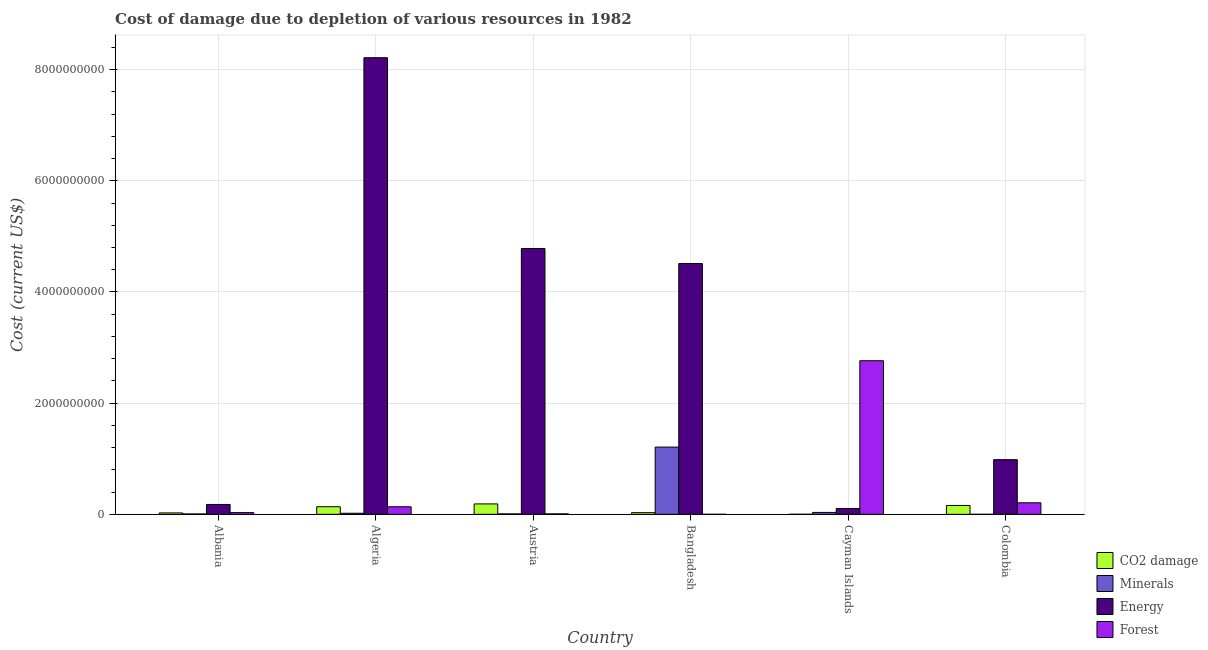Are the number of bars per tick equal to the number of legend labels?
Provide a short and direct response. Yes. Are the number of bars on each tick of the X-axis equal?
Provide a short and direct response. Yes. How many bars are there on the 3rd tick from the left?
Your answer should be compact. 4. What is the label of the 1st group of bars from the left?
Your answer should be very brief. Albania. In how many cases, is the number of bars for a given country not equal to the number of legend labels?
Keep it short and to the point. 0. What is the cost of damage due to depletion of forests in Bangladesh?
Keep it short and to the point. 2.95e+05. Across all countries, what is the maximum cost of damage due to depletion of forests?
Provide a short and direct response. 2.76e+09. Across all countries, what is the minimum cost of damage due to depletion of energy?
Your answer should be very brief. 1.05e+08. In which country was the cost of damage due to depletion of minerals maximum?
Give a very brief answer. Bangladesh. In which country was the cost of damage due to depletion of forests minimum?
Ensure brevity in your answer.  Bangladesh. What is the total cost of damage due to depletion of forests in the graph?
Provide a succinct answer. 3.15e+09. What is the difference between the cost of damage due to depletion of coal in Austria and that in Colombia?
Your answer should be very brief. 2.76e+07. What is the difference between the cost of damage due to depletion of energy in Cayman Islands and the cost of damage due to depletion of coal in Austria?
Provide a short and direct response. -8.20e+07. What is the average cost of damage due to depletion of energy per country?
Your answer should be very brief. 3.13e+09. What is the difference between the cost of damage due to depletion of energy and cost of damage due to depletion of minerals in Albania?
Provide a succinct answer. 1.71e+08. In how many countries, is the cost of damage due to depletion of forests greater than 2000000000 US$?
Offer a very short reply. 1. What is the ratio of the cost of damage due to depletion of forests in Algeria to that in Cayman Islands?
Your answer should be compact. 0.05. What is the difference between the highest and the second highest cost of damage due to depletion of minerals?
Your answer should be very brief. 1.18e+09. What is the difference between the highest and the lowest cost of damage due to depletion of forests?
Provide a succinct answer. 2.76e+09. In how many countries, is the cost of damage due to depletion of minerals greater than the average cost of damage due to depletion of minerals taken over all countries?
Ensure brevity in your answer.  1. Is the sum of the cost of damage due to depletion of minerals in Cayman Islands and Colombia greater than the maximum cost of damage due to depletion of forests across all countries?
Keep it short and to the point. No. Is it the case that in every country, the sum of the cost of damage due to depletion of coal and cost of damage due to depletion of forests is greater than the sum of cost of damage due to depletion of energy and cost of damage due to depletion of minerals?
Ensure brevity in your answer.  No. What does the 4th bar from the left in Cayman Islands represents?
Offer a terse response. Forest. What does the 2nd bar from the right in Albania represents?
Your answer should be very brief. Energy. How many bars are there?
Ensure brevity in your answer.  24. Are all the bars in the graph horizontal?
Your response must be concise. No. Does the graph contain any zero values?
Your response must be concise. No. Does the graph contain grids?
Give a very brief answer. Yes. How many legend labels are there?
Provide a succinct answer. 4. How are the legend labels stacked?
Make the answer very short. Vertical. What is the title of the graph?
Offer a terse response. Cost of damage due to depletion of various resources in 1982 . What is the label or title of the Y-axis?
Offer a terse response. Cost (current US$). What is the Cost (current US$) of CO2 damage in Albania?
Give a very brief answer. 2.54e+07. What is the Cost (current US$) in Minerals in Albania?
Make the answer very short. 6.87e+06. What is the Cost (current US$) in Energy in Albania?
Make the answer very short. 1.77e+08. What is the Cost (current US$) in Forest in Albania?
Ensure brevity in your answer.  3.07e+07. What is the Cost (current US$) in CO2 damage in Algeria?
Your answer should be compact. 1.36e+08. What is the Cost (current US$) in Minerals in Algeria?
Offer a terse response. 1.92e+07. What is the Cost (current US$) in Energy in Algeria?
Keep it short and to the point. 8.21e+09. What is the Cost (current US$) in Forest in Algeria?
Keep it short and to the point. 1.36e+08. What is the Cost (current US$) of CO2 damage in Austria?
Your answer should be very brief. 1.87e+08. What is the Cost (current US$) in Minerals in Austria?
Offer a terse response. 7.86e+06. What is the Cost (current US$) in Energy in Austria?
Offer a terse response. 4.78e+09. What is the Cost (current US$) in Forest in Austria?
Provide a short and direct response. 8.02e+06. What is the Cost (current US$) in CO2 damage in Bangladesh?
Give a very brief answer. 2.99e+07. What is the Cost (current US$) of Minerals in Bangladesh?
Make the answer very short. 1.21e+09. What is the Cost (current US$) of Energy in Bangladesh?
Give a very brief answer. 4.51e+09. What is the Cost (current US$) in Forest in Bangladesh?
Your answer should be compact. 2.95e+05. What is the Cost (current US$) in CO2 damage in Cayman Islands?
Give a very brief answer. 5.73e+05. What is the Cost (current US$) in Minerals in Cayman Islands?
Keep it short and to the point. 3.43e+07. What is the Cost (current US$) in Energy in Cayman Islands?
Give a very brief answer. 1.05e+08. What is the Cost (current US$) of Forest in Cayman Islands?
Your answer should be compact. 2.76e+09. What is the Cost (current US$) in CO2 damage in Colombia?
Give a very brief answer. 1.59e+08. What is the Cost (current US$) of Minerals in Colombia?
Give a very brief answer. 7726.01. What is the Cost (current US$) of Energy in Colombia?
Give a very brief answer. 9.83e+08. What is the Cost (current US$) in Forest in Colombia?
Your answer should be compact. 2.08e+08. Across all countries, what is the maximum Cost (current US$) of CO2 damage?
Your answer should be very brief. 1.87e+08. Across all countries, what is the maximum Cost (current US$) in Minerals?
Make the answer very short. 1.21e+09. Across all countries, what is the maximum Cost (current US$) in Energy?
Keep it short and to the point. 8.21e+09. Across all countries, what is the maximum Cost (current US$) in Forest?
Offer a terse response. 2.76e+09. Across all countries, what is the minimum Cost (current US$) of CO2 damage?
Your response must be concise. 5.73e+05. Across all countries, what is the minimum Cost (current US$) in Minerals?
Ensure brevity in your answer.  7726.01. Across all countries, what is the minimum Cost (current US$) in Energy?
Your response must be concise. 1.05e+08. Across all countries, what is the minimum Cost (current US$) in Forest?
Provide a succinct answer. 2.95e+05. What is the total Cost (current US$) of CO2 damage in the graph?
Give a very brief answer. 5.39e+08. What is the total Cost (current US$) of Minerals in the graph?
Keep it short and to the point. 1.28e+09. What is the total Cost (current US$) of Energy in the graph?
Provide a short and direct response. 1.88e+1. What is the total Cost (current US$) in Forest in the graph?
Your response must be concise. 3.15e+09. What is the difference between the Cost (current US$) of CO2 damage in Albania and that in Algeria?
Your answer should be compact. -1.11e+08. What is the difference between the Cost (current US$) of Minerals in Albania and that in Algeria?
Your answer should be compact. -1.23e+07. What is the difference between the Cost (current US$) in Energy in Albania and that in Algeria?
Offer a very short reply. -8.04e+09. What is the difference between the Cost (current US$) in Forest in Albania and that in Algeria?
Offer a terse response. -1.05e+08. What is the difference between the Cost (current US$) of CO2 damage in Albania and that in Austria?
Your answer should be compact. -1.62e+08. What is the difference between the Cost (current US$) of Minerals in Albania and that in Austria?
Your answer should be compact. -9.95e+05. What is the difference between the Cost (current US$) of Energy in Albania and that in Austria?
Your answer should be compact. -4.60e+09. What is the difference between the Cost (current US$) in Forest in Albania and that in Austria?
Your response must be concise. 2.26e+07. What is the difference between the Cost (current US$) of CO2 damage in Albania and that in Bangladesh?
Keep it short and to the point. -4.48e+06. What is the difference between the Cost (current US$) of Minerals in Albania and that in Bangladesh?
Offer a very short reply. -1.20e+09. What is the difference between the Cost (current US$) of Energy in Albania and that in Bangladesh?
Your answer should be compact. -4.33e+09. What is the difference between the Cost (current US$) in Forest in Albania and that in Bangladesh?
Offer a terse response. 3.04e+07. What is the difference between the Cost (current US$) of CO2 damage in Albania and that in Cayman Islands?
Your answer should be very brief. 2.48e+07. What is the difference between the Cost (current US$) in Minerals in Albania and that in Cayman Islands?
Your answer should be very brief. -2.74e+07. What is the difference between the Cost (current US$) in Energy in Albania and that in Cayman Islands?
Provide a succinct answer. 7.23e+07. What is the difference between the Cost (current US$) in Forest in Albania and that in Cayman Islands?
Provide a succinct answer. -2.73e+09. What is the difference between the Cost (current US$) of CO2 damage in Albania and that in Colombia?
Provide a short and direct response. -1.34e+08. What is the difference between the Cost (current US$) in Minerals in Albania and that in Colombia?
Keep it short and to the point. 6.86e+06. What is the difference between the Cost (current US$) in Energy in Albania and that in Colombia?
Offer a terse response. -8.06e+08. What is the difference between the Cost (current US$) in Forest in Albania and that in Colombia?
Provide a succinct answer. -1.77e+08. What is the difference between the Cost (current US$) in CO2 damage in Algeria and that in Austria?
Offer a very short reply. -5.07e+07. What is the difference between the Cost (current US$) of Minerals in Algeria and that in Austria?
Keep it short and to the point. 1.13e+07. What is the difference between the Cost (current US$) of Energy in Algeria and that in Austria?
Your response must be concise. 3.43e+09. What is the difference between the Cost (current US$) of Forest in Algeria and that in Austria?
Offer a very short reply. 1.28e+08. What is the difference between the Cost (current US$) in CO2 damage in Algeria and that in Bangladesh?
Your answer should be very brief. 1.07e+08. What is the difference between the Cost (current US$) in Minerals in Algeria and that in Bangladesh?
Give a very brief answer. -1.19e+09. What is the difference between the Cost (current US$) in Energy in Algeria and that in Bangladesh?
Provide a succinct answer. 3.70e+09. What is the difference between the Cost (current US$) of Forest in Algeria and that in Bangladesh?
Your response must be concise. 1.36e+08. What is the difference between the Cost (current US$) of CO2 damage in Algeria and that in Cayman Islands?
Your answer should be compact. 1.36e+08. What is the difference between the Cost (current US$) of Minerals in Algeria and that in Cayman Islands?
Offer a terse response. -1.51e+07. What is the difference between the Cost (current US$) in Energy in Algeria and that in Cayman Islands?
Keep it short and to the point. 8.11e+09. What is the difference between the Cost (current US$) of Forest in Algeria and that in Cayman Islands?
Provide a succinct answer. -2.63e+09. What is the difference between the Cost (current US$) of CO2 damage in Algeria and that in Colombia?
Provide a short and direct response. -2.31e+07. What is the difference between the Cost (current US$) of Minerals in Algeria and that in Colombia?
Ensure brevity in your answer.  1.92e+07. What is the difference between the Cost (current US$) of Energy in Algeria and that in Colombia?
Make the answer very short. 7.23e+09. What is the difference between the Cost (current US$) in Forest in Algeria and that in Colombia?
Give a very brief answer. -7.17e+07. What is the difference between the Cost (current US$) in CO2 damage in Austria and that in Bangladesh?
Your answer should be very brief. 1.57e+08. What is the difference between the Cost (current US$) in Minerals in Austria and that in Bangladesh?
Offer a terse response. -1.20e+09. What is the difference between the Cost (current US$) of Energy in Austria and that in Bangladesh?
Provide a short and direct response. 2.70e+08. What is the difference between the Cost (current US$) in Forest in Austria and that in Bangladesh?
Give a very brief answer. 7.72e+06. What is the difference between the Cost (current US$) in CO2 damage in Austria and that in Cayman Islands?
Your response must be concise. 1.87e+08. What is the difference between the Cost (current US$) of Minerals in Austria and that in Cayman Islands?
Make the answer very short. -2.64e+07. What is the difference between the Cost (current US$) of Energy in Austria and that in Cayman Islands?
Offer a very short reply. 4.68e+09. What is the difference between the Cost (current US$) in Forest in Austria and that in Cayman Islands?
Keep it short and to the point. -2.76e+09. What is the difference between the Cost (current US$) of CO2 damage in Austria and that in Colombia?
Give a very brief answer. 2.76e+07. What is the difference between the Cost (current US$) of Minerals in Austria and that in Colombia?
Keep it short and to the point. 7.85e+06. What is the difference between the Cost (current US$) of Energy in Austria and that in Colombia?
Ensure brevity in your answer.  3.80e+09. What is the difference between the Cost (current US$) in Forest in Austria and that in Colombia?
Provide a short and direct response. -2.00e+08. What is the difference between the Cost (current US$) of CO2 damage in Bangladesh and that in Cayman Islands?
Keep it short and to the point. 2.93e+07. What is the difference between the Cost (current US$) in Minerals in Bangladesh and that in Cayman Islands?
Ensure brevity in your answer.  1.18e+09. What is the difference between the Cost (current US$) of Energy in Bangladesh and that in Cayman Islands?
Provide a short and direct response. 4.41e+09. What is the difference between the Cost (current US$) in Forest in Bangladesh and that in Cayman Islands?
Your answer should be compact. -2.76e+09. What is the difference between the Cost (current US$) in CO2 damage in Bangladesh and that in Colombia?
Provide a succinct answer. -1.30e+08. What is the difference between the Cost (current US$) in Minerals in Bangladesh and that in Colombia?
Your response must be concise. 1.21e+09. What is the difference between the Cost (current US$) in Energy in Bangladesh and that in Colombia?
Your answer should be very brief. 3.53e+09. What is the difference between the Cost (current US$) of Forest in Bangladesh and that in Colombia?
Give a very brief answer. -2.07e+08. What is the difference between the Cost (current US$) of CO2 damage in Cayman Islands and that in Colombia?
Give a very brief answer. -1.59e+08. What is the difference between the Cost (current US$) in Minerals in Cayman Islands and that in Colombia?
Ensure brevity in your answer.  3.43e+07. What is the difference between the Cost (current US$) in Energy in Cayman Islands and that in Colombia?
Your answer should be compact. -8.78e+08. What is the difference between the Cost (current US$) in Forest in Cayman Islands and that in Colombia?
Provide a short and direct response. 2.56e+09. What is the difference between the Cost (current US$) of CO2 damage in Albania and the Cost (current US$) of Minerals in Algeria?
Offer a terse response. 6.20e+06. What is the difference between the Cost (current US$) of CO2 damage in Albania and the Cost (current US$) of Energy in Algeria?
Your answer should be compact. -8.19e+09. What is the difference between the Cost (current US$) in CO2 damage in Albania and the Cost (current US$) in Forest in Algeria?
Give a very brief answer. -1.11e+08. What is the difference between the Cost (current US$) of Minerals in Albania and the Cost (current US$) of Energy in Algeria?
Your response must be concise. -8.21e+09. What is the difference between the Cost (current US$) in Minerals in Albania and the Cost (current US$) in Forest in Algeria?
Offer a very short reply. -1.29e+08. What is the difference between the Cost (current US$) of Energy in Albania and the Cost (current US$) of Forest in Algeria?
Give a very brief answer. 4.15e+07. What is the difference between the Cost (current US$) in CO2 damage in Albania and the Cost (current US$) in Minerals in Austria?
Offer a very short reply. 1.75e+07. What is the difference between the Cost (current US$) of CO2 damage in Albania and the Cost (current US$) of Energy in Austria?
Offer a very short reply. -4.76e+09. What is the difference between the Cost (current US$) of CO2 damage in Albania and the Cost (current US$) of Forest in Austria?
Provide a short and direct response. 1.74e+07. What is the difference between the Cost (current US$) of Minerals in Albania and the Cost (current US$) of Energy in Austria?
Offer a terse response. -4.78e+09. What is the difference between the Cost (current US$) of Minerals in Albania and the Cost (current US$) of Forest in Austria?
Offer a very short reply. -1.15e+06. What is the difference between the Cost (current US$) of Energy in Albania and the Cost (current US$) of Forest in Austria?
Your response must be concise. 1.69e+08. What is the difference between the Cost (current US$) in CO2 damage in Albania and the Cost (current US$) in Minerals in Bangladesh?
Provide a succinct answer. -1.18e+09. What is the difference between the Cost (current US$) in CO2 damage in Albania and the Cost (current US$) in Energy in Bangladesh?
Your answer should be very brief. -4.49e+09. What is the difference between the Cost (current US$) of CO2 damage in Albania and the Cost (current US$) of Forest in Bangladesh?
Your answer should be compact. 2.51e+07. What is the difference between the Cost (current US$) in Minerals in Albania and the Cost (current US$) in Energy in Bangladesh?
Offer a terse response. -4.51e+09. What is the difference between the Cost (current US$) in Minerals in Albania and the Cost (current US$) in Forest in Bangladesh?
Offer a terse response. 6.57e+06. What is the difference between the Cost (current US$) of Energy in Albania and the Cost (current US$) of Forest in Bangladesh?
Your answer should be compact. 1.77e+08. What is the difference between the Cost (current US$) in CO2 damage in Albania and the Cost (current US$) in Minerals in Cayman Islands?
Offer a terse response. -8.88e+06. What is the difference between the Cost (current US$) in CO2 damage in Albania and the Cost (current US$) in Energy in Cayman Islands?
Your answer should be compact. -7.97e+07. What is the difference between the Cost (current US$) in CO2 damage in Albania and the Cost (current US$) in Forest in Cayman Islands?
Your answer should be very brief. -2.74e+09. What is the difference between the Cost (current US$) of Minerals in Albania and the Cost (current US$) of Energy in Cayman Islands?
Ensure brevity in your answer.  -9.82e+07. What is the difference between the Cost (current US$) of Minerals in Albania and the Cost (current US$) of Forest in Cayman Islands?
Provide a succinct answer. -2.76e+09. What is the difference between the Cost (current US$) in Energy in Albania and the Cost (current US$) in Forest in Cayman Islands?
Provide a succinct answer. -2.59e+09. What is the difference between the Cost (current US$) in CO2 damage in Albania and the Cost (current US$) in Minerals in Colombia?
Your answer should be very brief. 2.54e+07. What is the difference between the Cost (current US$) in CO2 damage in Albania and the Cost (current US$) in Energy in Colombia?
Keep it short and to the point. -9.58e+08. What is the difference between the Cost (current US$) in CO2 damage in Albania and the Cost (current US$) in Forest in Colombia?
Keep it short and to the point. -1.82e+08. What is the difference between the Cost (current US$) in Minerals in Albania and the Cost (current US$) in Energy in Colombia?
Provide a succinct answer. -9.76e+08. What is the difference between the Cost (current US$) of Minerals in Albania and the Cost (current US$) of Forest in Colombia?
Your answer should be compact. -2.01e+08. What is the difference between the Cost (current US$) in Energy in Albania and the Cost (current US$) in Forest in Colombia?
Your answer should be compact. -3.02e+07. What is the difference between the Cost (current US$) of CO2 damage in Algeria and the Cost (current US$) of Minerals in Austria?
Provide a short and direct response. 1.29e+08. What is the difference between the Cost (current US$) of CO2 damage in Algeria and the Cost (current US$) of Energy in Austria?
Your answer should be compact. -4.65e+09. What is the difference between the Cost (current US$) in CO2 damage in Algeria and the Cost (current US$) in Forest in Austria?
Ensure brevity in your answer.  1.28e+08. What is the difference between the Cost (current US$) of Minerals in Algeria and the Cost (current US$) of Energy in Austria?
Provide a short and direct response. -4.76e+09. What is the difference between the Cost (current US$) of Minerals in Algeria and the Cost (current US$) of Forest in Austria?
Offer a very short reply. 1.12e+07. What is the difference between the Cost (current US$) of Energy in Algeria and the Cost (current US$) of Forest in Austria?
Provide a succinct answer. 8.21e+09. What is the difference between the Cost (current US$) in CO2 damage in Algeria and the Cost (current US$) in Minerals in Bangladesh?
Give a very brief answer. -1.07e+09. What is the difference between the Cost (current US$) of CO2 damage in Algeria and the Cost (current US$) of Energy in Bangladesh?
Give a very brief answer. -4.38e+09. What is the difference between the Cost (current US$) of CO2 damage in Algeria and the Cost (current US$) of Forest in Bangladesh?
Ensure brevity in your answer.  1.36e+08. What is the difference between the Cost (current US$) of Minerals in Algeria and the Cost (current US$) of Energy in Bangladesh?
Your answer should be compact. -4.49e+09. What is the difference between the Cost (current US$) of Minerals in Algeria and the Cost (current US$) of Forest in Bangladesh?
Your answer should be compact. 1.89e+07. What is the difference between the Cost (current US$) of Energy in Algeria and the Cost (current US$) of Forest in Bangladesh?
Give a very brief answer. 8.21e+09. What is the difference between the Cost (current US$) of CO2 damage in Algeria and the Cost (current US$) of Minerals in Cayman Islands?
Keep it short and to the point. 1.02e+08. What is the difference between the Cost (current US$) of CO2 damage in Algeria and the Cost (current US$) of Energy in Cayman Islands?
Offer a terse response. 3.13e+07. What is the difference between the Cost (current US$) in CO2 damage in Algeria and the Cost (current US$) in Forest in Cayman Islands?
Your response must be concise. -2.63e+09. What is the difference between the Cost (current US$) in Minerals in Algeria and the Cost (current US$) in Energy in Cayman Islands?
Keep it short and to the point. -8.59e+07. What is the difference between the Cost (current US$) in Minerals in Algeria and the Cost (current US$) in Forest in Cayman Islands?
Provide a succinct answer. -2.74e+09. What is the difference between the Cost (current US$) of Energy in Algeria and the Cost (current US$) of Forest in Cayman Islands?
Make the answer very short. 5.45e+09. What is the difference between the Cost (current US$) of CO2 damage in Algeria and the Cost (current US$) of Minerals in Colombia?
Offer a very short reply. 1.36e+08. What is the difference between the Cost (current US$) of CO2 damage in Algeria and the Cost (current US$) of Energy in Colombia?
Your answer should be very brief. -8.47e+08. What is the difference between the Cost (current US$) of CO2 damage in Algeria and the Cost (current US$) of Forest in Colombia?
Give a very brief answer. -7.12e+07. What is the difference between the Cost (current US$) of Minerals in Algeria and the Cost (current US$) of Energy in Colombia?
Your answer should be compact. -9.64e+08. What is the difference between the Cost (current US$) in Minerals in Algeria and the Cost (current US$) in Forest in Colombia?
Give a very brief answer. -1.88e+08. What is the difference between the Cost (current US$) of Energy in Algeria and the Cost (current US$) of Forest in Colombia?
Ensure brevity in your answer.  8.01e+09. What is the difference between the Cost (current US$) of CO2 damage in Austria and the Cost (current US$) of Minerals in Bangladesh?
Offer a very short reply. -1.02e+09. What is the difference between the Cost (current US$) in CO2 damage in Austria and the Cost (current US$) in Energy in Bangladesh?
Provide a succinct answer. -4.33e+09. What is the difference between the Cost (current US$) in CO2 damage in Austria and the Cost (current US$) in Forest in Bangladesh?
Provide a succinct answer. 1.87e+08. What is the difference between the Cost (current US$) in Minerals in Austria and the Cost (current US$) in Energy in Bangladesh?
Offer a very short reply. -4.50e+09. What is the difference between the Cost (current US$) of Minerals in Austria and the Cost (current US$) of Forest in Bangladesh?
Make the answer very short. 7.57e+06. What is the difference between the Cost (current US$) in Energy in Austria and the Cost (current US$) in Forest in Bangladesh?
Make the answer very short. 4.78e+09. What is the difference between the Cost (current US$) in CO2 damage in Austria and the Cost (current US$) in Minerals in Cayman Islands?
Provide a succinct answer. 1.53e+08. What is the difference between the Cost (current US$) in CO2 damage in Austria and the Cost (current US$) in Energy in Cayman Islands?
Offer a very short reply. 8.20e+07. What is the difference between the Cost (current US$) in CO2 damage in Austria and the Cost (current US$) in Forest in Cayman Islands?
Provide a short and direct response. -2.58e+09. What is the difference between the Cost (current US$) in Minerals in Austria and the Cost (current US$) in Energy in Cayman Islands?
Offer a terse response. -9.72e+07. What is the difference between the Cost (current US$) of Minerals in Austria and the Cost (current US$) of Forest in Cayman Islands?
Keep it short and to the point. -2.76e+09. What is the difference between the Cost (current US$) of Energy in Austria and the Cost (current US$) of Forest in Cayman Islands?
Offer a very short reply. 2.02e+09. What is the difference between the Cost (current US$) of CO2 damage in Austria and the Cost (current US$) of Minerals in Colombia?
Keep it short and to the point. 1.87e+08. What is the difference between the Cost (current US$) in CO2 damage in Austria and the Cost (current US$) in Energy in Colombia?
Provide a short and direct response. -7.96e+08. What is the difference between the Cost (current US$) in CO2 damage in Austria and the Cost (current US$) in Forest in Colombia?
Provide a succinct answer. -2.05e+07. What is the difference between the Cost (current US$) in Minerals in Austria and the Cost (current US$) in Energy in Colombia?
Ensure brevity in your answer.  -9.75e+08. What is the difference between the Cost (current US$) of Minerals in Austria and the Cost (current US$) of Forest in Colombia?
Make the answer very short. -2.00e+08. What is the difference between the Cost (current US$) in Energy in Austria and the Cost (current US$) in Forest in Colombia?
Your response must be concise. 4.57e+09. What is the difference between the Cost (current US$) of CO2 damage in Bangladesh and the Cost (current US$) of Minerals in Cayman Islands?
Your response must be concise. -4.40e+06. What is the difference between the Cost (current US$) in CO2 damage in Bangladesh and the Cost (current US$) in Energy in Cayman Islands?
Give a very brief answer. -7.52e+07. What is the difference between the Cost (current US$) of CO2 damage in Bangladesh and the Cost (current US$) of Forest in Cayman Islands?
Ensure brevity in your answer.  -2.73e+09. What is the difference between the Cost (current US$) in Minerals in Bangladesh and the Cost (current US$) in Energy in Cayman Islands?
Provide a short and direct response. 1.10e+09. What is the difference between the Cost (current US$) in Minerals in Bangladesh and the Cost (current US$) in Forest in Cayman Islands?
Keep it short and to the point. -1.55e+09. What is the difference between the Cost (current US$) in Energy in Bangladesh and the Cost (current US$) in Forest in Cayman Islands?
Provide a succinct answer. 1.75e+09. What is the difference between the Cost (current US$) in CO2 damage in Bangladesh and the Cost (current US$) in Minerals in Colombia?
Your answer should be compact. 2.99e+07. What is the difference between the Cost (current US$) of CO2 damage in Bangladesh and the Cost (current US$) of Energy in Colombia?
Keep it short and to the point. -9.53e+08. What is the difference between the Cost (current US$) of CO2 damage in Bangladesh and the Cost (current US$) of Forest in Colombia?
Keep it short and to the point. -1.78e+08. What is the difference between the Cost (current US$) of Minerals in Bangladesh and the Cost (current US$) of Energy in Colombia?
Keep it short and to the point. 2.26e+08. What is the difference between the Cost (current US$) in Minerals in Bangladesh and the Cost (current US$) in Forest in Colombia?
Ensure brevity in your answer.  1.00e+09. What is the difference between the Cost (current US$) in Energy in Bangladesh and the Cost (current US$) in Forest in Colombia?
Your answer should be very brief. 4.30e+09. What is the difference between the Cost (current US$) of CO2 damage in Cayman Islands and the Cost (current US$) of Minerals in Colombia?
Offer a terse response. 5.65e+05. What is the difference between the Cost (current US$) in CO2 damage in Cayman Islands and the Cost (current US$) in Energy in Colombia?
Make the answer very short. -9.83e+08. What is the difference between the Cost (current US$) of CO2 damage in Cayman Islands and the Cost (current US$) of Forest in Colombia?
Your answer should be very brief. -2.07e+08. What is the difference between the Cost (current US$) of Minerals in Cayman Islands and the Cost (current US$) of Energy in Colombia?
Provide a short and direct response. -9.49e+08. What is the difference between the Cost (current US$) of Minerals in Cayman Islands and the Cost (current US$) of Forest in Colombia?
Offer a very short reply. -1.73e+08. What is the difference between the Cost (current US$) of Energy in Cayman Islands and the Cost (current US$) of Forest in Colombia?
Offer a terse response. -1.02e+08. What is the average Cost (current US$) in CO2 damage per country?
Give a very brief answer. 8.98e+07. What is the average Cost (current US$) of Minerals per country?
Provide a succinct answer. 2.13e+08. What is the average Cost (current US$) of Energy per country?
Your response must be concise. 3.13e+09. What is the average Cost (current US$) in Forest per country?
Your answer should be compact. 5.24e+08. What is the difference between the Cost (current US$) in CO2 damage and Cost (current US$) in Minerals in Albania?
Your answer should be compact. 1.85e+07. What is the difference between the Cost (current US$) in CO2 damage and Cost (current US$) in Energy in Albania?
Give a very brief answer. -1.52e+08. What is the difference between the Cost (current US$) of CO2 damage and Cost (current US$) of Forest in Albania?
Your answer should be very brief. -5.27e+06. What is the difference between the Cost (current US$) in Minerals and Cost (current US$) in Energy in Albania?
Keep it short and to the point. -1.71e+08. What is the difference between the Cost (current US$) of Minerals and Cost (current US$) of Forest in Albania?
Offer a terse response. -2.38e+07. What is the difference between the Cost (current US$) in Energy and Cost (current US$) in Forest in Albania?
Ensure brevity in your answer.  1.47e+08. What is the difference between the Cost (current US$) in CO2 damage and Cost (current US$) in Minerals in Algeria?
Offer a terse response. 1.17e+08. What is the difference between the Cost (current US$) in CO2 damage and Cost (current US$) in Energy in Algeria?
Provide a short and direct response. -8.08e+09. What is the difference between the Cost (current US$) of CO2 damage and Cost (current US$) of Forest in Algeria?
Give a very brief answer. 4.85e+05. What is the difference between the Cost (current US$) of Minerals and Cost (current US$) of Energy in Algeria?
Make the answer very short. -8.20e+09. What is the difference between the Cost (current US$) of Minerals and Cost (current US$) of Forest in Algeria?
Your answer should be very brief. -1.17e+08. What is the difference between the Cost (current US$) of Energy and Cost (current US$) of Forest in Algeria?
Ensure brevity in your answer.  8.08e+09. What is the difference between the Cost (current US$) in CO2 damage and Cost (current US$) in Minerals in Austria?
Offer a very short reply. 1.79e+08. What is the difference between the Cost (current US$) in CO2 damage and Cost (current US$) in Energy in Austria?
Your answer should be compact. -4.59e+09. What is the difference between the Cost (current US$) of CO2 damage and Cost (current US$) of Forest in Austria?
Provide a succinct answer. 1.79e+08. What is the difference between the Cost (current US$) in Minerals and Cost (current US$) in Energy in Austria?
Offer a very short reply. -4.77e+09. What is the difference between the Cost (current US$) in Minerals and Cost (current US$) in Forest in Austria?
Your answer should be very brief. -1.59e+05. What is the difference between the Cost (current US$) of Energy and Cost (current US$) of Forest in Austria?
Your response must be concise. 4.77e+09. What is the difference between the Cost (current US$) of CO2 damage and Cost (current US$) of Minerals in Bangladesh?
Provide a short and direct response. -1.18e+09. What is the difference between the Cost (current US$) in CO2 damage and Cost (current US$) in Energy in Bangladesh?
Make the answer very short. -4.48e+09. What is the difference between the Cost (current US$) in CO2 damage and Cost (current US$) in Forest in Bangladesh?
Provide a succinct answer. 2.96e+07. What is the difference between the Cost (current US$) in Minerals and Cost (current US$) in Energy in Bangladesh?
Your answer should be very brief. -3.30e+09. What is the difference between the Cost (current US$) of Minerals and Cost (current US$) of Forest in Bangladesh?
Give a very brief answer. 1.21e+09. What is the difference between the Cost (current US$) in Energy and Cost (current US$) in Forest in Bangladesh?
Provide a succinct answer. 4.51e+09. What is the difference between the Cost (current US$) in CO2 damage and Cost (current US$) in Minerals in Cayman Islands?
Provide a succinct answer. -3.37e+07. What is the difference between the Cost (current US$) in CO2 damage and Cost (current US$) in Energy in Cayman Islands?
Your answer should be compact. -1.05e+08. What is the difference between the Cost (current US$) of CO2 damage and Cost (current US$) of Forest in Cayman Islands?
Give a very brief answer. -2.76e+09. What is the difference between the Cost (current US$) of Minerals and Cost (current US$) of Energy in Cayman Islands?
Offer a very short reply. -7.08e+07. What is the difference between the Cost (current US$) of Minerals and Cost (current US$) of Forest in Cayman Islands?
Offer a terse response. -2.73e+09. What is the difference between the Cost (current US$) of Energy and Cost (current US$) of Forest in Cayman Islands?
Keep it short and to the point. -2.66e+09. What is the difference between the Cost (current US$) of CO2 damage and Cost (current US$) of Minerals in Colombia?
Provide a short and direct response. 1.59e+08. What is the difference between the Cost (current US$) of CO2 damage and Cost (current US$) of Energy in Colombia?
Offer a very short reply. -8.24e+08. What is the difference between the Cost (current US$) of CO2 damage and Cost (current US$) of Forest in Colombia?
Ensure brevity in your answer.  -4.81e+07. What is the difference between the Cost (current US$) of Minerals and Cost (current US$) of Energy in Colombia?
Offer a very short reply. -9.83e+08. What is the difference between the Cost (current US$) in Minerals and Cost (current US$) in Forest in Colombia?
Ensure brevity in your answer.  -2.08e+08. What is the difference between the Cost (current US$) in Energy and Cost (current US$) in Forest in Colombia?
Offer a very short reply. 7.76e+08. What is the ratio of the Cost (current US$) of CO2 damage in Albania to that in Algeria?
Ensure brevity in your answer.  0.19. What is the ratio of the Cost (current US$) of Minerals in Albania to that in Algeria?
Your answer should be very brief. 0.36. What is the ratio of the Cost (current US$) in Energy in Albania to that in Algeria?
Provide a succinct answer. 0.02. What is the ratio of the Cost (current US$) of Forest in Albania to that in Algeria?
Your answer should be compact. 0.23. What is the ratio of the Cost (current US$) of CO2 damage in Albania to that in Austria?
Keep it short and to the point. 0.14. What is the ratio of the Cost (current US$) in Minerals in Albania to that in Austria?
Give a very brief answer. 0.87. What is the ratio of the Cost (current US$) in Energy in Albania to that in Austria?
Offer a terse response. 0.04. What is the ratio of the Cost (current US$) in Forest in Albania to that in Austria?
Your answer should be very brief. 3.82. What is the ratio of the Cost (current US$) in CO2 damage in Albania to that in Bangladesh?
Offer a terse response. 0.85. What is the ratio of the Cost (current US$) in Minerals in Albania to that in Bangladesh?
Your answer should be very brief. 0.01. What is the ratio of the Cost (current US$) of Energy in Albania to that in Bangladesh?
Provide a succinct answer. 0.04. What is the ratio of the Cost (current US$) of Forest in Albania to that in Bangladesh?
Your response must be concise. 103.98. What is the ratio of the Cost (current US$) of CO2 damage in Albania to that in Cayman Islands?
Offer a very short reply. 44.29. What is the ratio of the Cost (current US$) of Minerals in Albania to that in Cayman Islands?
Your answer should be very brief. 0.2. What is the ratio of the Cost (current US$) of Energy in Albania to that in Cayman Islands?
Your answer should be compact. 1.69. What is the ratio of the Cost (current US$) of Forest in Albania to that in Cayman Islands?
Your answer should be very brief. 0.01. What is the ratio of the Cost (current US$) in CO2 damage in Albania to that in Colombia?
Offer a very short reply. 0.16. What is the ratio of the Cost (current US$) of Minerals in Albania to that in Colombia?
Provide a succinct answer. 888.63. What is the ratio of the Cost (current US$) in Energy in Albania to that in Colombia?
Provide a short and direct response. 0.18. What is the ratio of the Cost (current US$) in Forest in Albania to that in Colombia?
Offer a very short reply. 0.15. What is the ratio of the Cost (current US$) of CO2 damage in Algeria to that in Austria?
Offer a terse response. 0.73. What is the ratio of the Cost (current US$) in Minerals in Algeria to that in Austria?
Your response must be concise. 2.44. What is the ratio of the Cost (current US$) of Energy in Algeria to that in Austria?
Offer a very short reply. 1.72. What is the ratio of the Cost (current US$) in Forest in Algeria to that in Austria?
Keep it short and to the point. 16.95. What is the ratio of the Cost (current US$) in CO2 damage in Algeria to that in Bangladesh?
Make the answer very short. 4.57. What is the ratio of the Cost (current US$) in Minerals in Algeria to that in Bangladesh?
Give a very brief answer. 0.02. What is the ratio of the Cost (current US$) of Energy in Algeria to that in Bangladesh?
Give a very brief answer. 1.82. What is the ratio of the Cost (current US$) in Forest in Algeria to that in Bangladesh?
Provide a short and direct response. 460.96. What is the ratio of the Cost (current US$) of CO2 damage in Algeria to that in Cayman Islands?
Provide a succinct answer. 237.98. What is the ratio of the Cost (current US$) in Minerals in Algeria to that in Cayman Islands?
Ensure brevity in your answer.  0.56. What is the ratio of the Cost (current US$) in Energy in Algeria to that in Cayman Islands?
Give a very brief answer. 78.16. What is the ratio of the Cost (current US$) of Forest in Algeria to that in Cayman Islands?
Your answer should be compact. 0.05. What is the ratio of the Cost (current US$) of CO2 damage in Algeria to that in Colombia?
Make the answer very short. 0.86. What is the ratio of the Cost (current US$) of Minerals in Algeria to that in Colombia?
Ensure brevity in your answer.  2482.55. What is the ratio of the Cost (current US$) in Energy in Algeria to that in Colombia?
Your response must be concise. 8.36. What is the ratio of the Cost (current US$) of Forest in Algeria to that in Colombia?
Your answer should be very brief. 0.65. What is the ratio of the Cost (current US$) in CO2 damage in Austria to that in Bangladesh?
Provide a short and direct response. 6.26. What is the ratio of the Cost (current US$) of Minerals in Austria to that in Bangladesh?
Keep it short and to the point. 0.01. What is the ratio of the Cost (current US$) of Energy in Austria to that in Bangladesh?
Provide a short and direct response. 1.06. What is the ratio of the Cost (current US$) of Forest in Austria to that in Bangladesh?
Your response must be concise. 27.2. What is the ratio of the Cost (current US$) of CO2 damage in Austria to that in Cayman Islands?
Offer a very short reply. 326.44. What is the ratio of the Cost (current US$) in Minerals in Austria to that in Cayman Islands?
Offer a very short reply. 0.23. What is the ratio of the Cost (current US$) of Energy in Austria to that in Cayman Islands?
Keep it short and to the point. 45.5. What is the ratio of the Cost (current US$) of Forest in Austria to that in Cayman Islands?
Make the answer very short. 0. What is the ratio of the Cost (current US$) of CO2 damage in Austria to that in Colombia?
Keep it short and to the point. 1.17. What is the ratio of the Cost (current US$) in Minerals in Austria to that in Colombia?
Ensure brevity in your answer.  1017.43. What is the ratio of the Cost (current US$) of Energy in Austria to that in Colombia?
Provide a short and direct response. 4.86. What is the ratio of the Cost (current US$) in Forest in Austria to that in Colombia?
Your answer should be compact. 0.04. What is the ratio of the Cost (current US$) of CO2 damage in Bangladesh to that in Cayman Islands?
Offer a very short reply. 52.11. What is the ratio of the Cost (current US$) of Minerals in Bangladesh to that in Cayman Islands?
Make the answer very short. 35.29. What is the ratio of the Cost (current US$) in Energy in Bangladesh to that in Cayman Islands?
Your answer should be compact. 42.93. What is the ratio of the Cost (current US$) of Forest in Bangladesh to that in Cayman Islands?
Make the answer very short. 0. What is the ratio of the Cost (current US$) of CO2 damage in Bangladesh to that in Colombia?
Provide a short and direct response. 0.19. What is the ratio of the Cost (current US$) in Minerals in Bangladesh to that in Colombia?
Your response must be concise. 1.57e+05. What is the ratio of the Cost (current US$) in Energy in Bangladesh to that in Colombia?
Ensure brevity in your answer.  4.59. What is the ratio of the Cost (current US$) in Forest in Bangladesh to that in Colombia?
Provide a succinct answer. 0. What is the ratio of the Cost (current US$) of CO2 damage in Cayman Islands to that in Colombia?
Make the answer very short. 0. What is the ratio of the Cost (current US$) in Minerals in Cayman Islands to that in Colombia?
Provide a short and direct response. 4435.38. What is the ratio of the Cost (current US$) of Energy in Cayman Islands to that in Colombia?
Your response must be concise. 0.11. What is the ratio of the Cost (current US$) of Forest in Cayman Islands to that in Colombia?
Ensure brevity in your answer.  13.31. What is the difference between the highest and the second highest Cost (current US$) in CO2 damage?
Make the answer very short. 2.76e+07. What is the difference between the highest and the second highest Cost (current US$) of Minerals?
Your answer should be compact. 1.18e+09. What is the difference between the highest and the second highest Cost (current US$) in Energy?
Offer a terse response. 3.43e+09. What is the difference between the highest and the second highest Cost (current US$) in Forest?
Your response must be concise. 2.56e+09. What is the difference between the highest and the lowest Cost (current US$) in CO2 damage?
Offer a very short reply. 1.87e+08. What is the difference between the highest and the lowest Cost (current US$) in Minerals?
Provide a short and direct response. 1.21e+09. What is the difference between the highest and the lowest Cost (current US$) of Energy?
Make the answer very short. 8.11e+09. What is the difference between the highest and the lowest Cost (current US$) in Forest?
Ensure brevity in your answer.  2.76e+09. 